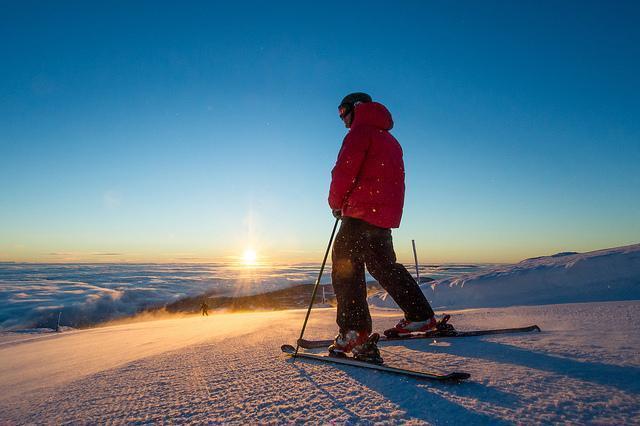Transport using skis to glide on snow is called?
Choose the right answer from the provided options to respond to the question.
Options: Surfing, skiing, snowboarding, kiting. Skiing. 